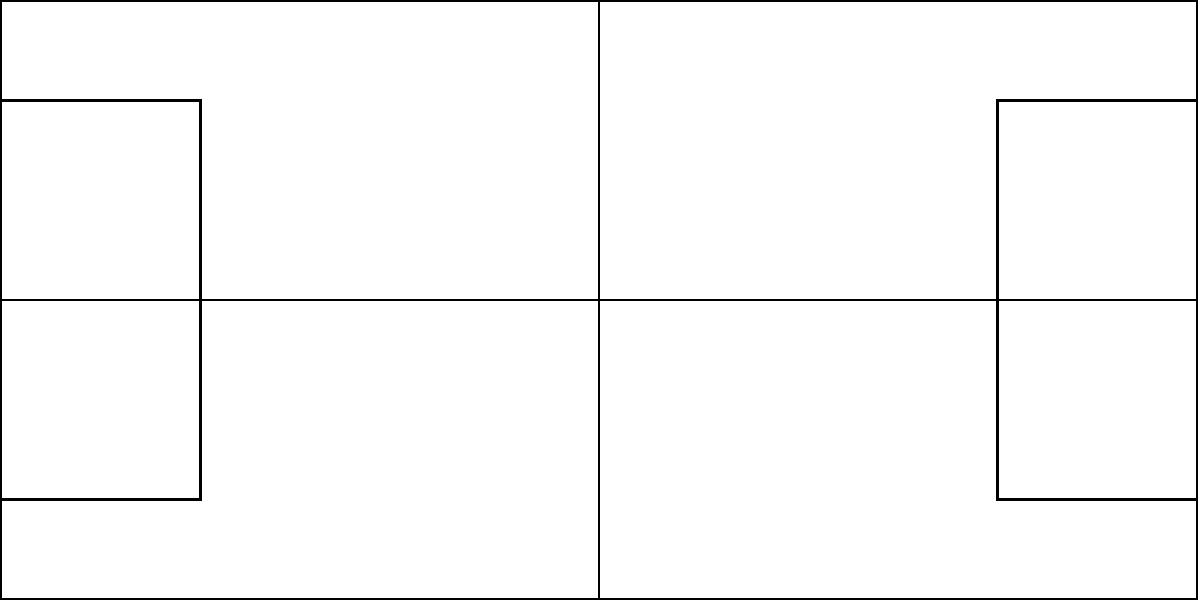Based on the heat map of Sloane Stephens' shot placement patterns shown above, which area of the court does she target most frequently with her shots? To determine the area of the court Sloane Stephens targets most frequently, we need to analyze the heat map:

1. The heat map uses color intensity to represent shot frequency, with darker red indicating higher frequency.
2. The tennis court is divided into a 6x5 grid, representing different areas of the court.
3. Examining the color intensities:
   - The lightest areas are near the net and the corners, indicating less frequent shots.
   - The intensity increases towards the back of the court.
   - The darkest red area is located in the center-back of the court, slightly to the right of center (from the player's perspective).
4. This darkest area corresponds to the deep center and deep deuce court (right side for a right-handed player).
5. The high intensity in this area suggests that Sloane Stephens frequently targets this region with her shots.

Given this analysis, we can conclude that Sloane Stephens most frequently targets the deep center and deep deuce court area with her shots.
Answer: Deep center and deep deuce court 